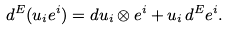<formula> <loc_0><loc_0><loc_500><loc_500>d ^ { E } ( u _ { i } e ^ { i } ) = d u _ { i } \otimes e ^ { i } + u _ { i } \, d ^ { E } e ^ { i } .</formula> 